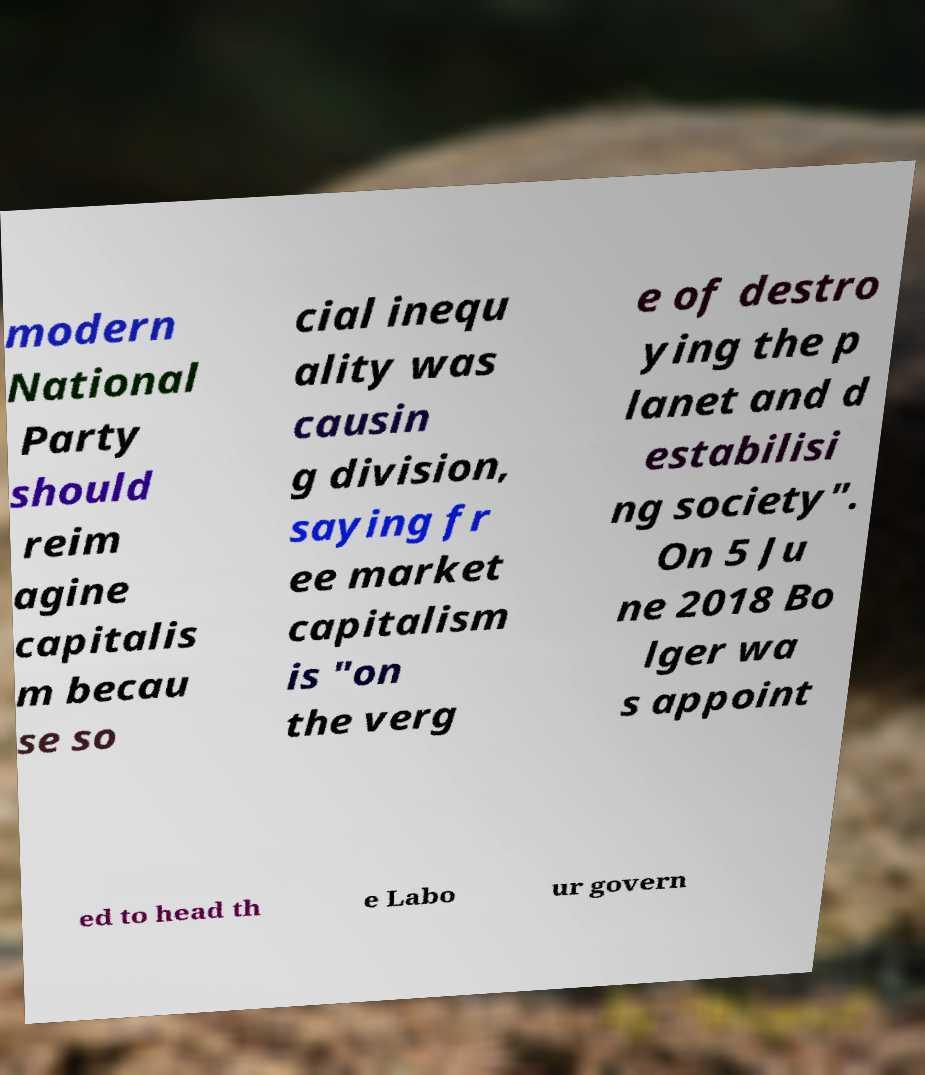Can you accurately transcribe the text from the provided image for me? modern National Party should reim agine capitalis m becau se so cial inequ ality was causin g division, saying fr ee market capitalism is "on the verg e of destro ying the p lanet and d estabilisi ng society". On 5 Ju ne 2018 Bo lger wa s appoint ed to head th e Labo ur govern 